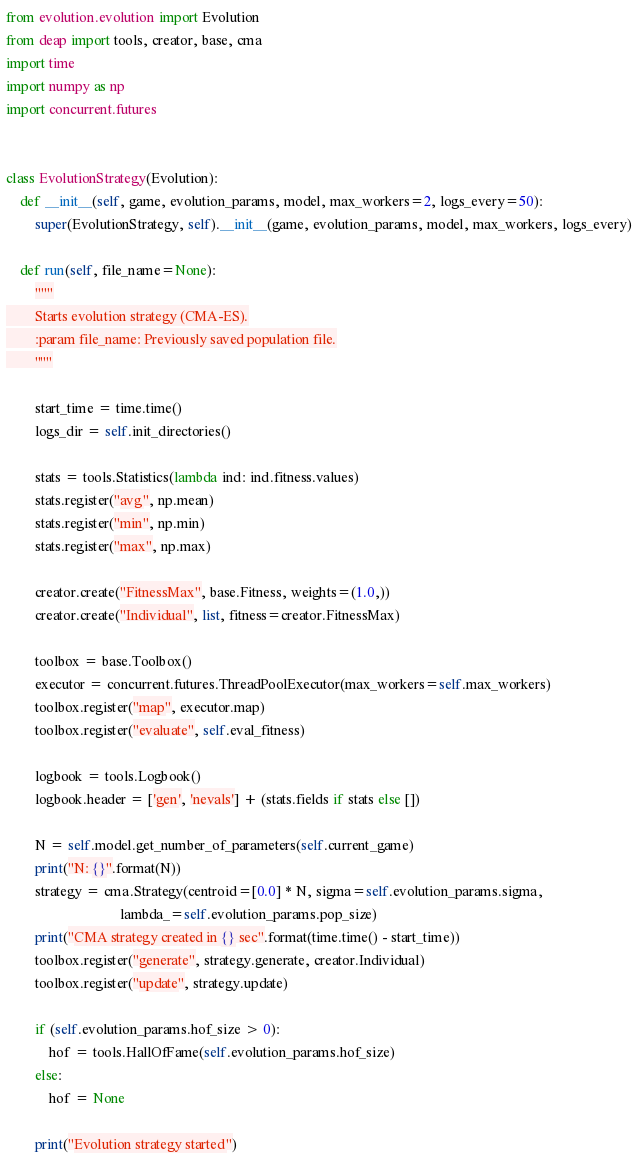Convert code to text. <code><loc_0><loc_0><loc_500><loc_500><_Python_>from evolution.evolution import Evolution
from deap import tools, creator, base, cma
import time
import numpy as np
import concurrent.futures


class EvolutionStrategy(Evolution):
    def __init__(self, game, evolution_params, model, max_workers=2, logs_every=50):
        super(EvolutionStrategy, self).__init__(game, evolution_params, model, max_workers, logs_every)

    def run(self, file_name=None):
        """
        Starts evolution strategy (CMA-ES).
        :param file_name: Previously saved population file.
        """

        start_time = time.time()
        logs_dir = self.init_directories()

        stats = tools.Statistics(lambda ind: ind.fitness.values)
        stats.register("avg", np.mean)
        stats.register("min", np.min)
        stats.register("max", np.max)

        creator.create("FitnessMax", base.Fitness, weights=(1.0,))
        creator.create("Individual", list, fitness=creator.FitnessMax)

        toolbox = base.Toolbox()
        executor = concurrent.futures.ThreadPoolExecutor(max_workers=self.max_workers)
        toolbox.register("map", executor.map)
        toolbox.register("evaluate", self.eval_fitness)

        logbook = tools.Logbook()
        logbook.header = ['gen', 'nevals'] + (stats.fields if stats else [])

        N = self.model.get_number_of_parameters(self.current_game)
        print("N: {}".format(N))
        strategy = cma.Strategy(centroid=[0.0] * N, sigma=self.evolution_params.sigma,
                                lambda_=self.evolution_params.pop_size)
        print("CMA strategy created in {} sec".format(time.time() - start_time))
        toolbox.register("generate", strategy.generate, creator.Individual)
        toolbox.register("update", strategy.update)

        if (self.evolution_params.hof_size > 0):
            hof = tools.HallOfFame(self.evolution_params.hof_size)
        else:
            hof = None

        print("Evolution strategy started")</code> 